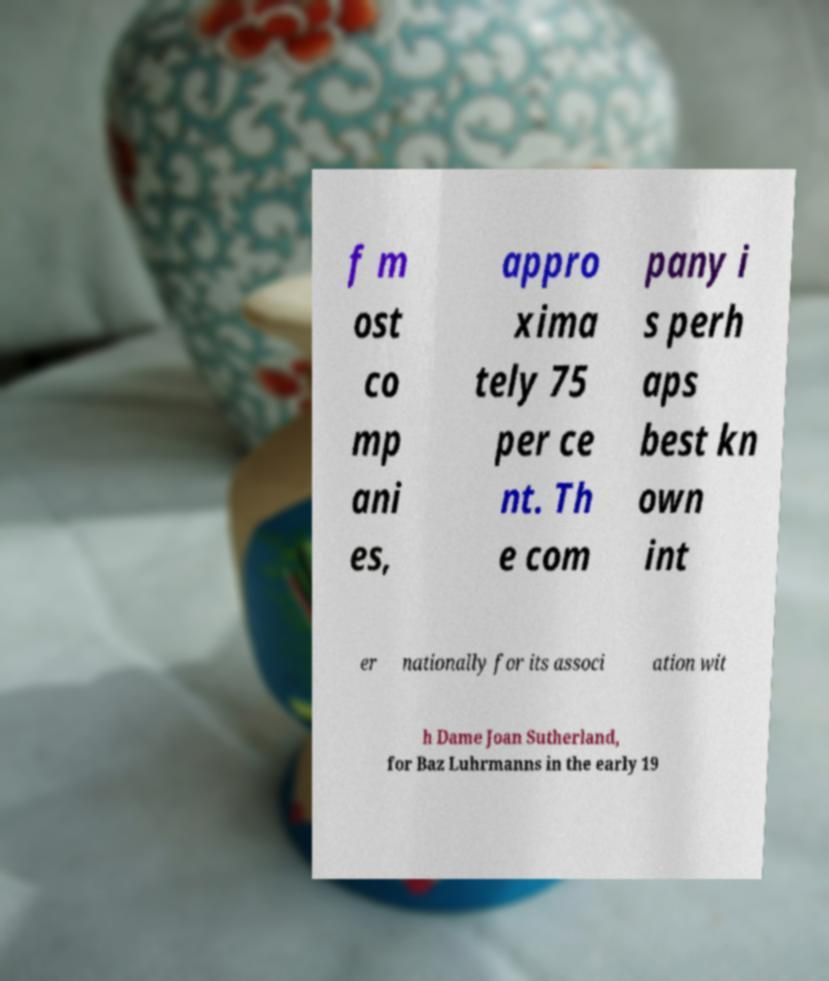For documentation purposes, I need the text within this image transcribed. Could you provide that? f m ost co mp ani es, appro xima tely 75 per ce nt. Th e com pany i s perh aps best kn own int er nationally for its associ ation wit h Dame Joan Sutherland, for Baz Luhrmanns in the early 19 